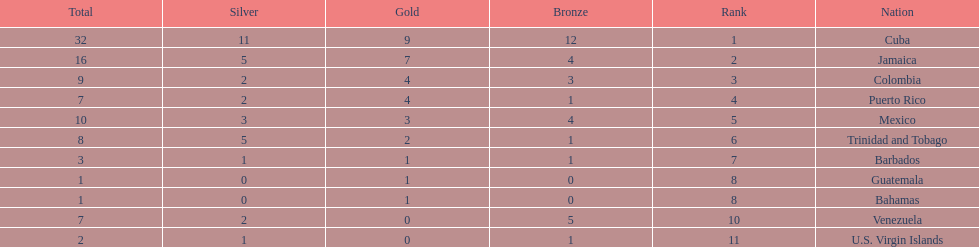Number of teams above 9 medals 3. 